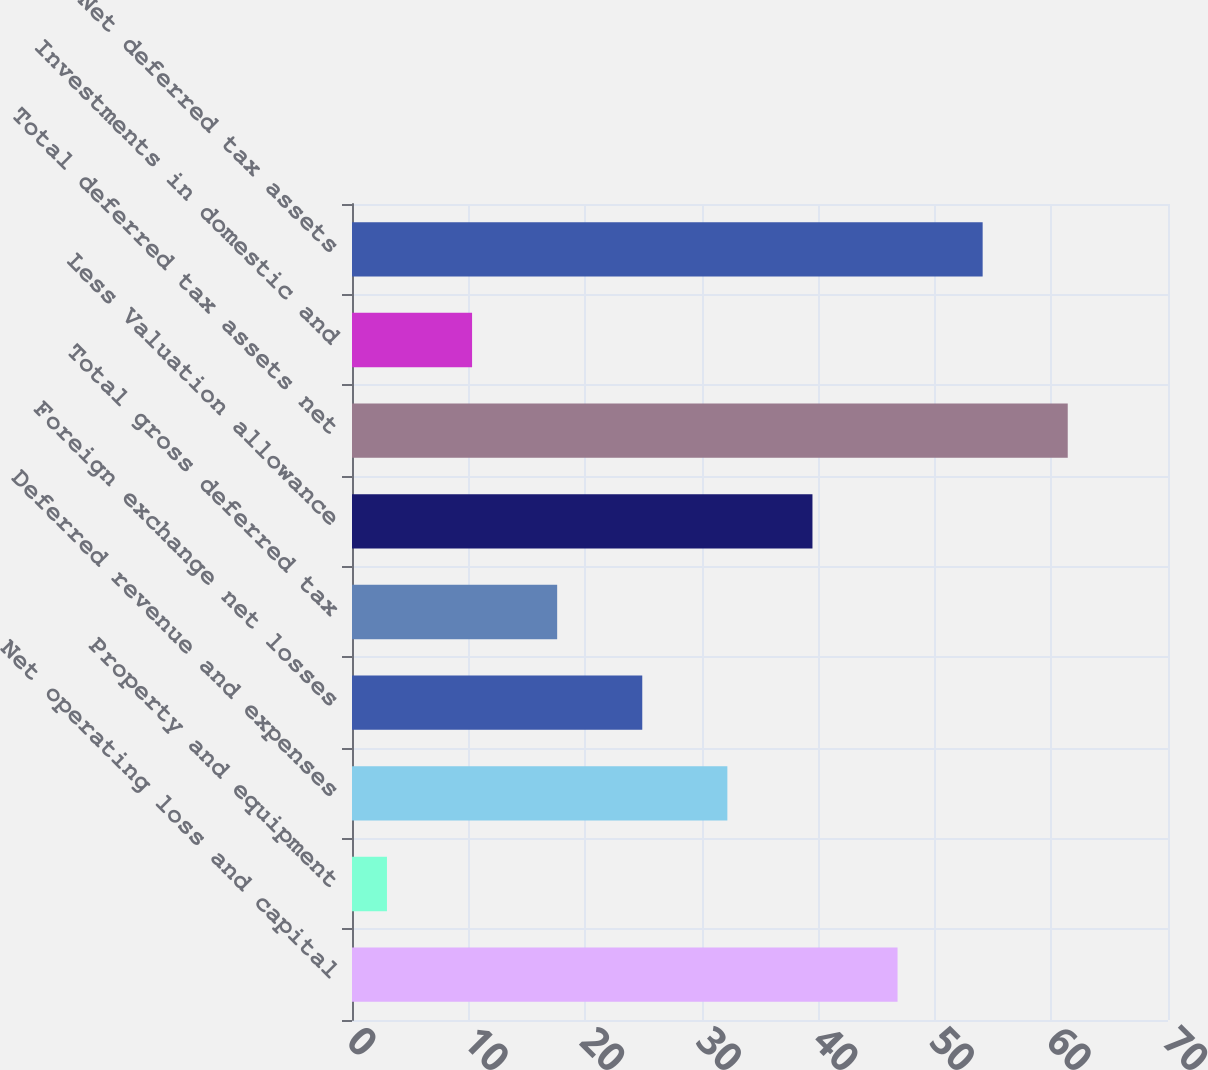Convert chart. <chart><loc_0><loc_0><loc_500><loc_500><bar_chart><fcel>Net operating loss and capital<fcel>Property and equipment<fcel>Deferred revenue and expenses<fcel>Foreign exchange net losses<fcel>Total gross deferred tax<fcel>Less Valuation allowance<fcel>Total deferred tax assets net<fcel>Investments in domestic and<fcel>Net deferred tax assets<nl><fcel>46.8<fcel>3<fcel>32.2<fcel>24.9<fcel>17.6<fcel>39.5<fcel>61.4<fcel>10.3<fcel>54.1<nl></chart> 